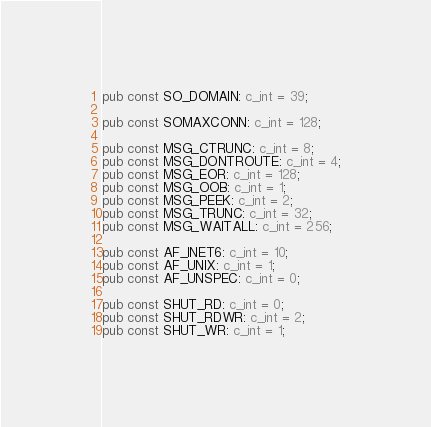Convert code to text. <code><loc_0><loc_0><loc_500><loc_500><_Rust_>pub const SO_DOMAIN: c_int = 39;

pub const SOMAXCONN: c_int = 128;

pub const MSG_CTRUNC: c_int = 8;
pub const MSG_DONTROUTE: c_int = 4;
pub const MSG_EOR: c_int = 128;
pub const MSG_OOB: c_int = 1;
pub const MSG_PEEK: c_int = 2;
pub const MSG_TRUNC: c_int = 32;
pub const MSG_WAITALL: c_int = 256;

pub const AF_INET6: c_int = 10;
pub const AF_UNIX: c_int = 1;
pub const AF_UNSPEC: c_int = 0;

pub const SHUT_RD: c_int = 0;
pub const SHUT_RDWR: c_int = 2;
pub const SHUT_WR: c_int = 1;
</code> 